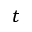Convert formula to latex. <formula><loc_0><loc_0><loc_500><loc_500>t</formula> 